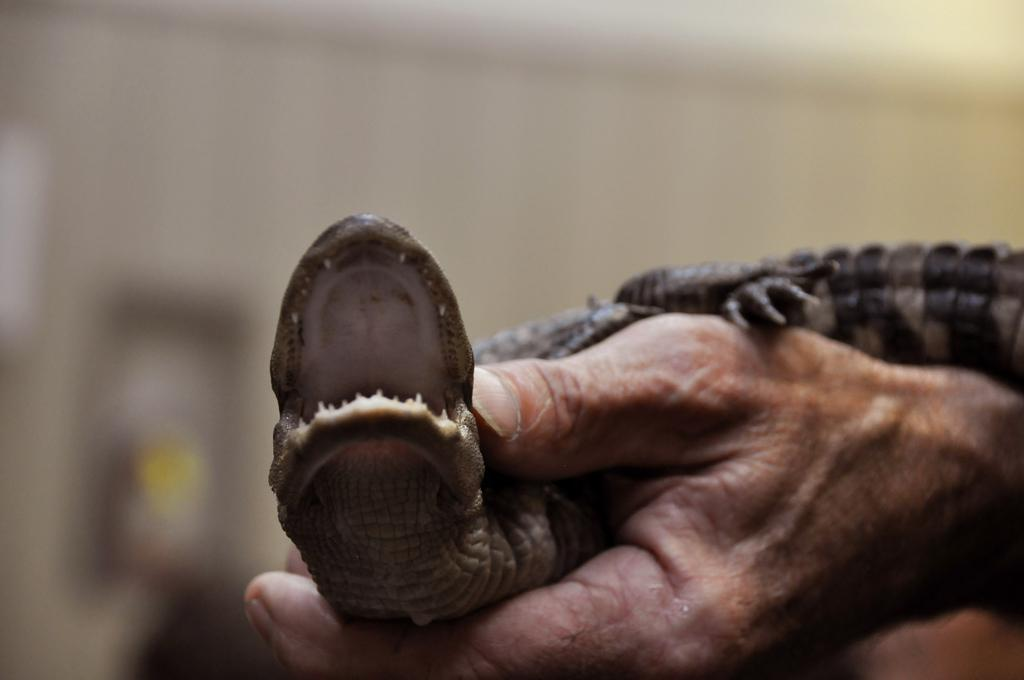What can be seen in the image that belongs to a person? There is a person's hand in the image. What is the person's hand holding? The hand is holding a reptile. Can you describe the background of the image? The background of the image appears blurred. What type of seed is being passed around in the image? There is no seed present in the image; it features a person's hand holding a reptile. How many people are in the group holding the note in the image? There is no group or note present in the image. 